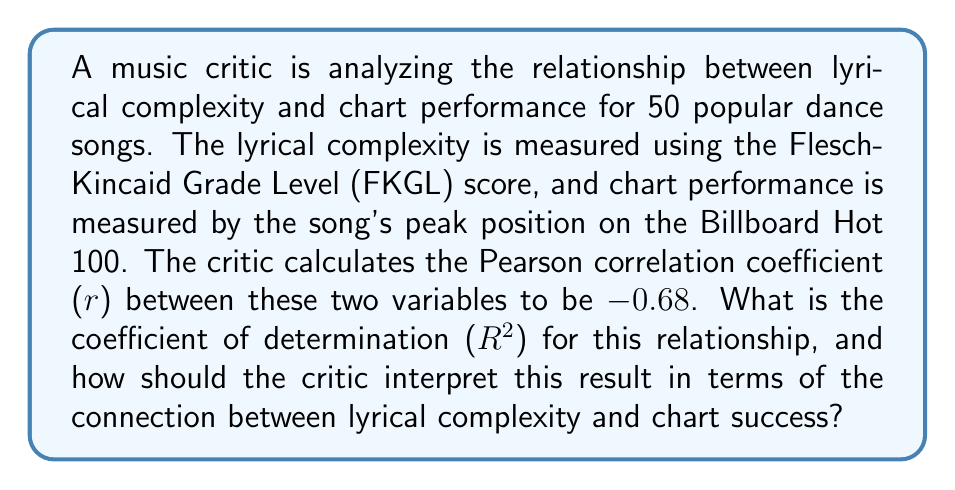Teach me how to tackle this problem. To solve this problem, we'll follow these steps:

1. Recall the relationship between the Pearson correlation coefficient (r) and the coefficient of determination (R²):

   $$R^2 = r^2$$

2. Calculate R² using the given r value:

   $$R^2 = (-0.68)^2 = 0.4624$$

3. Interpret the result:
   
   The coefficient of determination (R²) represents the proportion of variance in the dependent variable (chart performance) that is predictable from the independent variable (lyrical complexity).

   In this case, R² = 0.4624, which means that approximately 46.24% of the variance in chart performance can be explained by the lyrical complexity of the songs.

   The negative correlation coefficient (r = -0.68) indicates an inverse relationship between lyrical complexity and chart performance. This suggests that, on average, songs with lower lyrical complexity (lower FKGL scores) tend to perform better on the charts.

   However, it's important to note that while there is a moderate to strong negative correlation, it doesn't imply causation. Other factors not considered in this analysis may also influence chart performance.
Answer: $R^2 = 0.4624$; 46.24% of chart performance variance explained by lyrical complexity, with simpler lyrics generally performing better. 